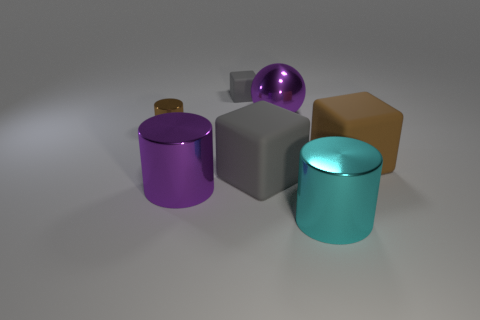Imagine these objects are part of a puzzle, how would you describe the way they fit together? If we were to consider these objects as pieces of a puzzle, their varying shapes suggest that each serves a unique purpose. The cylinders might act as containers or pillars, while the cube and sphere could serve as building blocks or elements that fit into corresponding holes or indents. The brown object, with its unique texture and shape, might be a key piece that signifies the completion of the puzzle. 